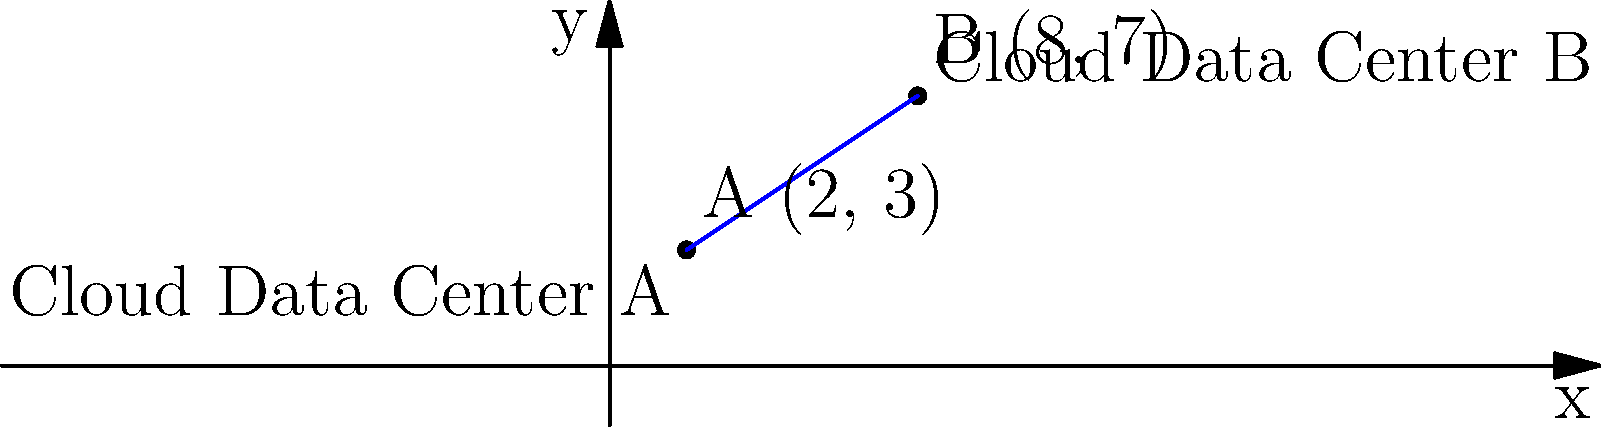Two cloud data centers are located on a coordinate plane. Data Center A is at coordinates (2, 3), and Data Center B is at coordinates (8, 7). Calculate the distance between these two data centers to determine the potential latency impact on cloud services. Round your answer to two decimal places. To calculate the distance between two points on a coordinate plane, we use the distance formula derived from the Pythagorean theorem:

$$ d = \sqrt{(x_2 - x_1)^2 + (y_2 - y_1)^2} $$

Where $(x_1, y_1)$ represents the coordinates of the first point and $(x_2, y_2)$ represents the coordinates of the second point.

Step 1: Identify the coordinates
Data Center A: $(x_1, y_1) = (2, 3)$
Data Center B: $(x_2, y_2) = (8, 7)$

Step 2: Plug the values into the distance formula
$$ d = \sqrt{(8 - 2)^2 + (7 - 3)^2} $$

Step 3: Simplify the expressions inside the parentheses
$$ d = \sqrt{6^2 + 4^2} $$

Step 4: Calculate the squares
$$ d = \sqrt{36 + 16} $$

Step 5: Add the values under the square root
$$ d = \sqrt{52} $$

Step 6: Calculate the square root and round to two decimal places
$$ d \approx 7.21 $$

Therefore, the distance between the two cloud data centers is approximately 7.21 units.
Answer: 7.21 units 